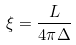Convert formula to latex. <formula><loc_0><loc_0><loc_500><loc_500>\xi = \frac { L } { 4 \pi \Delta }</formula> 